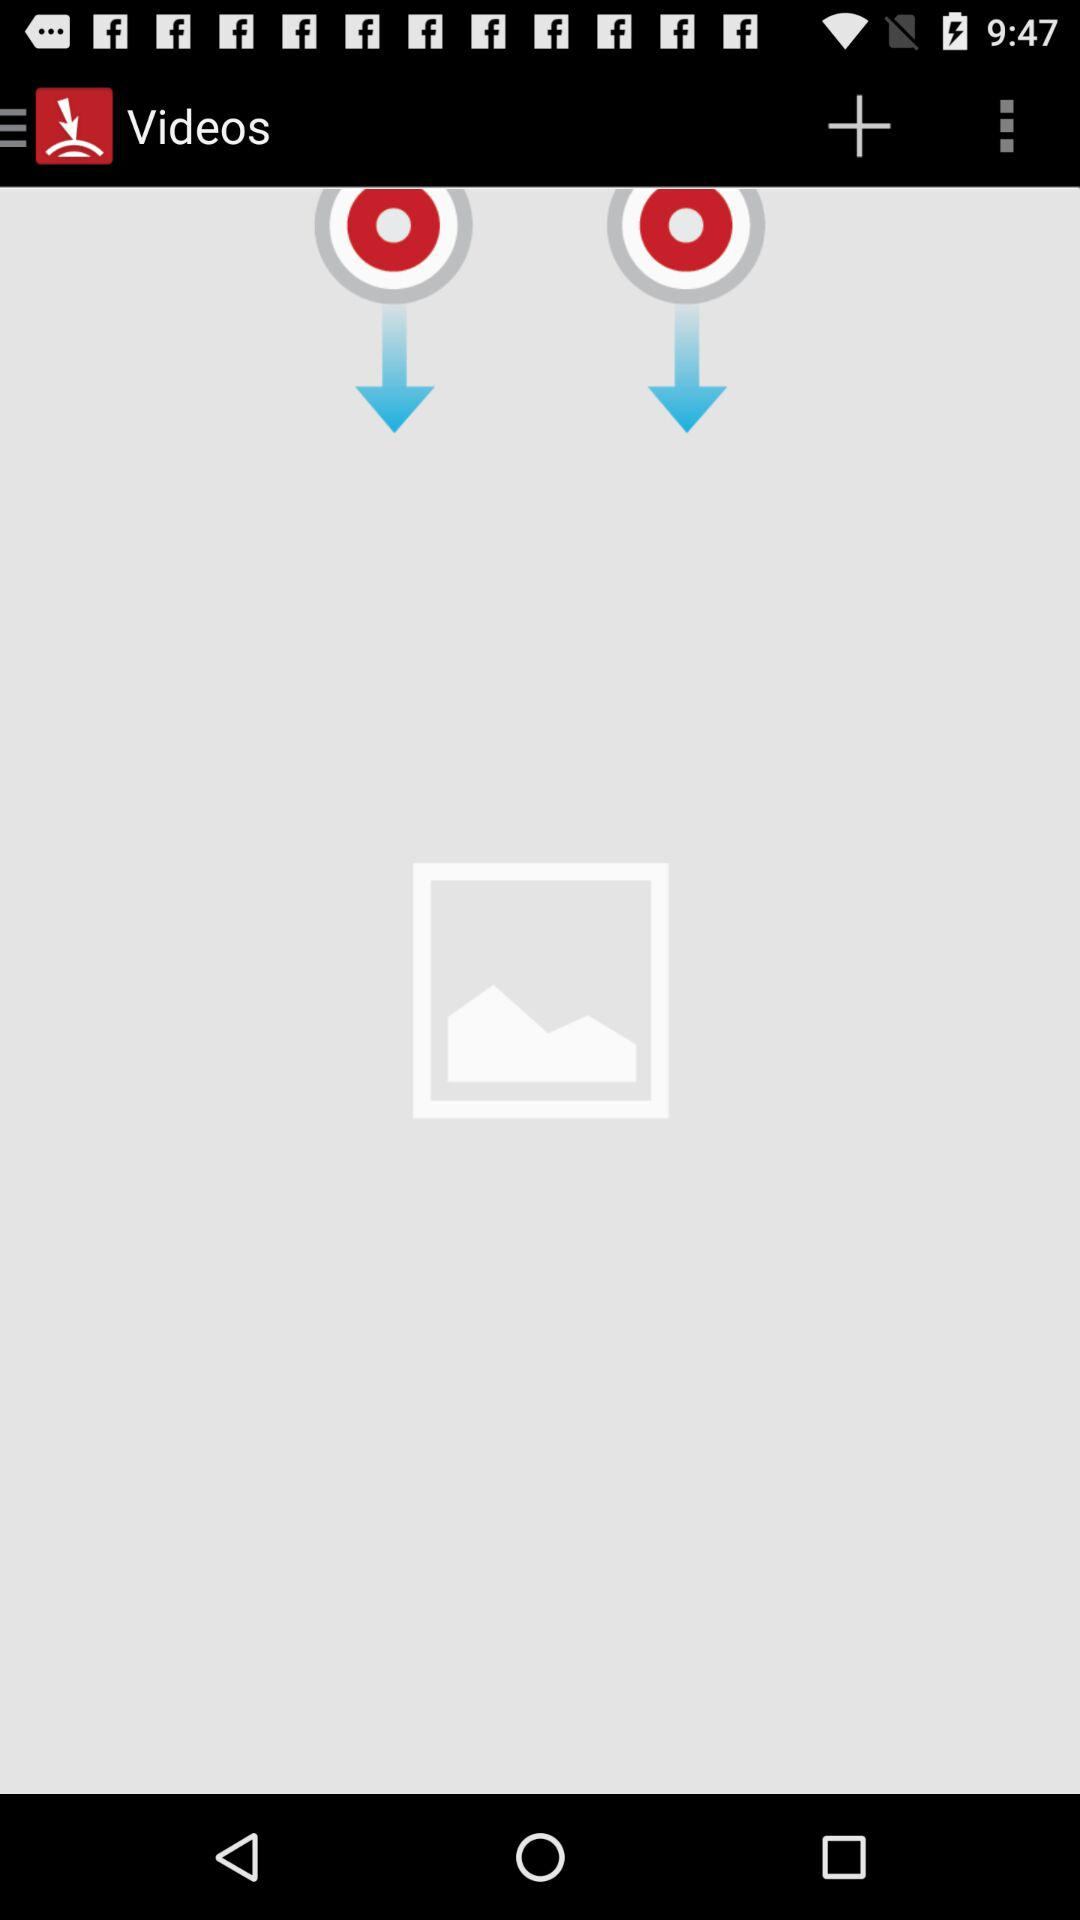How many more red circles with a white circle are there in the gallery than in the videos?
Answer the question using a single word or phrase. 1 